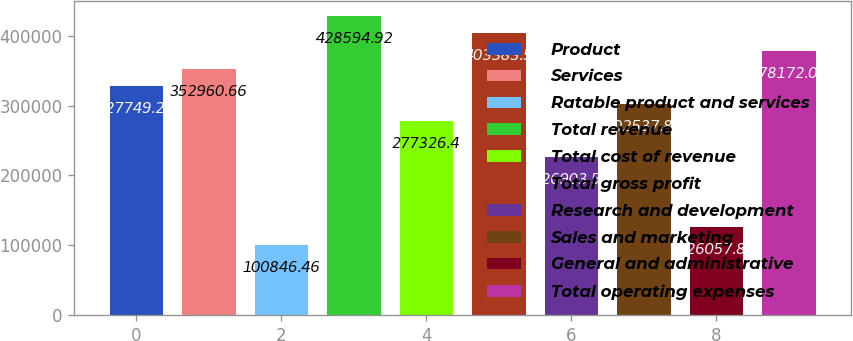Convert chart. <chart><loc_0><loc_0><loc_500><loc_500><bar_chart><fcel>Product<fcel>Services<fcel>Ratable product and services<fcel>Total revenue<fcel>Total cost of revenue<fcel>Total gross profit<fcel>Research and development<fcel>Sales and marketing<fcel>General and administrative<fcel>Total operating expenses<nl><fcel>327749<fcel>352961<fcel>100846<fcel>428595<fcel>277326<fcel>403384<fcel>226904<fcel>302538<fcel>126058<fcel>378172<nl></chart> 